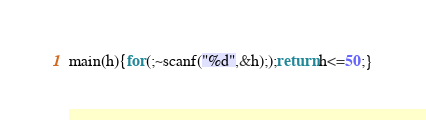<code> <loc_0><loc_0><loc_500><loc_500><_C_>main(h){for(;~scanf("%d",&h););return h<=50;}</code> 